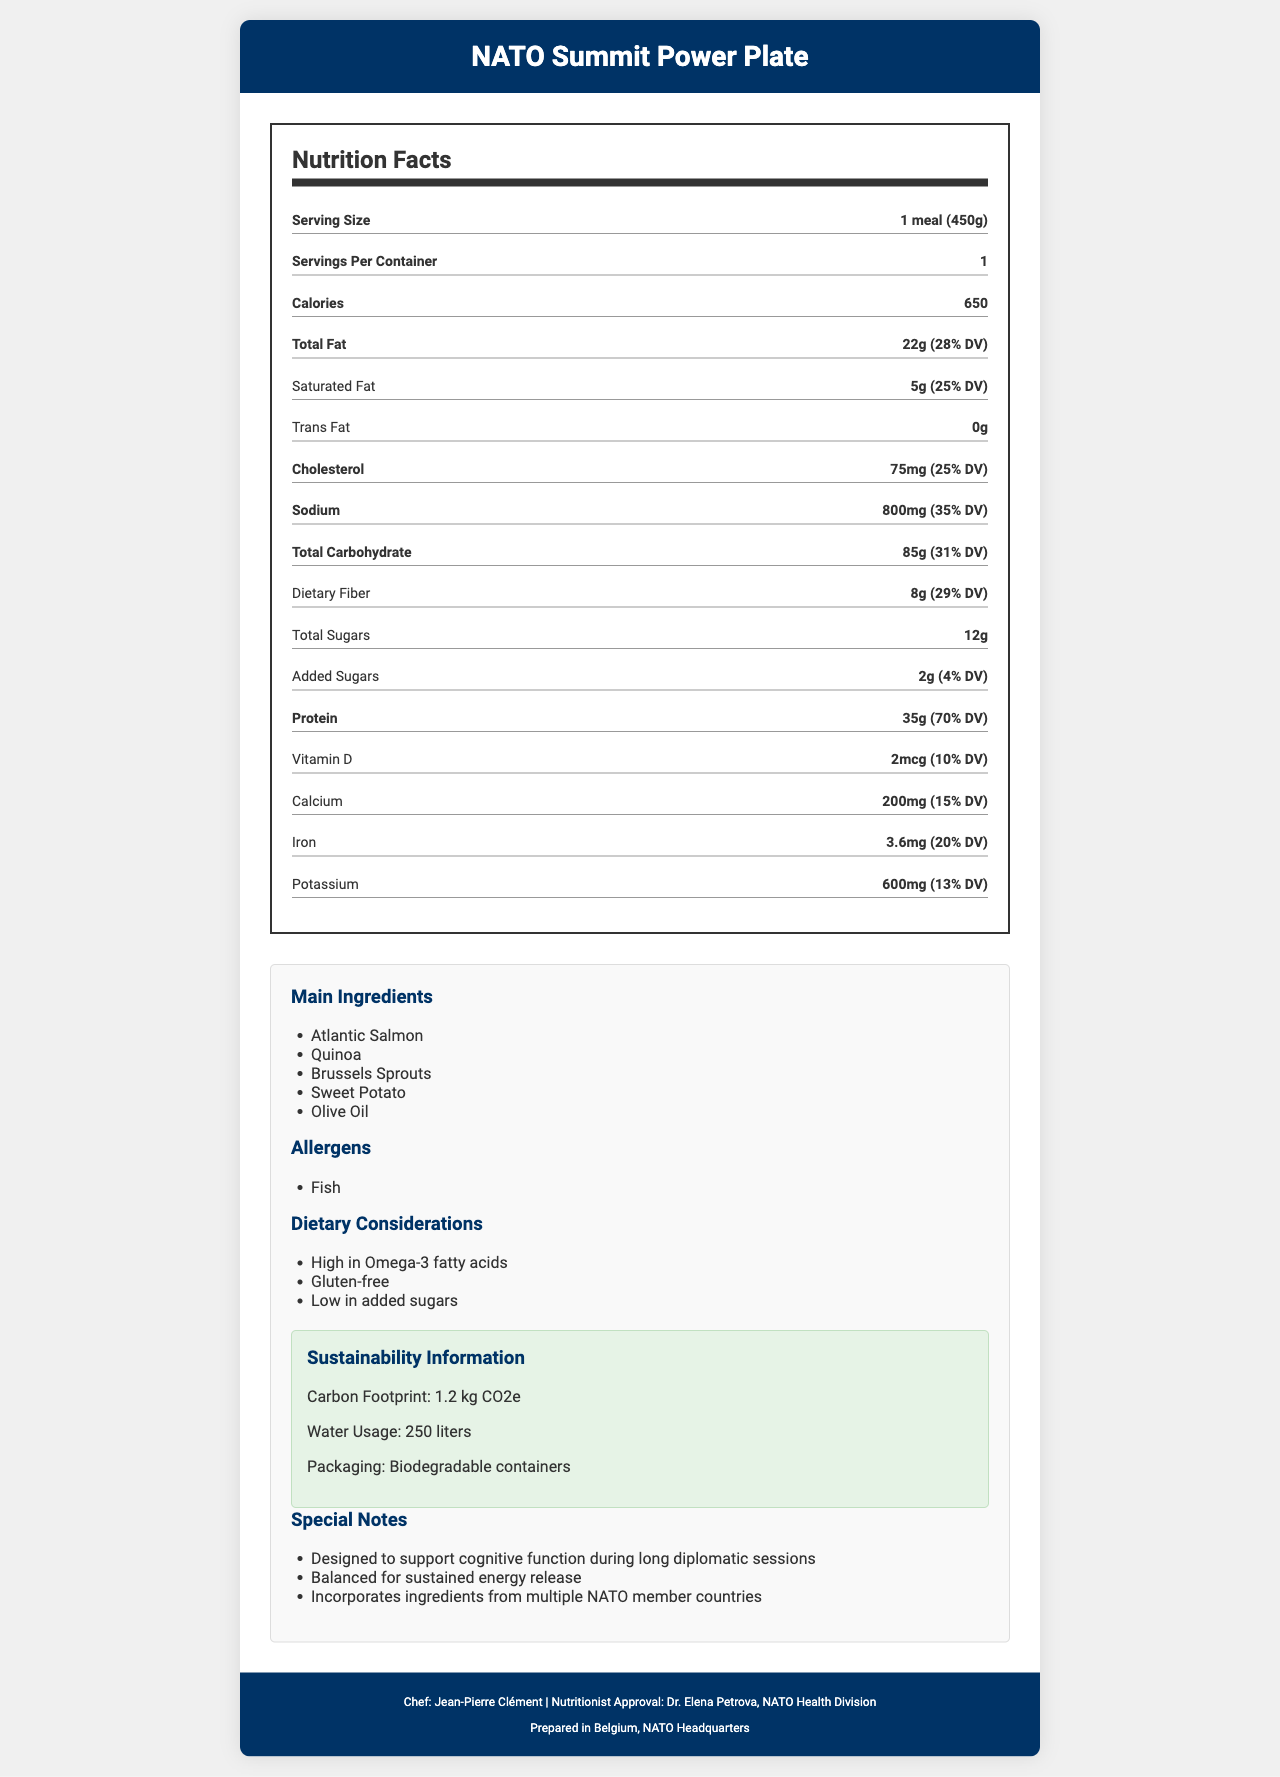what is the serving size of the meal? The serving size is clearly mentioned in the Nutrition Facts section as "1 meal (450g)".
Answer: 1 meal (450g) how many calories are in one meal? The Nutrition Facts section lists the calorie content as 650.
Answer: 650 what is the total amount of fat in grams and its daily value percentage? The Total Fat content is shown as 22g with a daily value percentage of 28%.
Answer: 22g, 28% which ingredient is the main source of protein in the meal? The main ingredients listed include Atlantic Salmon, which is known for its high protein content.
Answer: Atlantic Salmon does the meal contain any trans fat? The Nutrition Facts section indicates that the Trans Fat amount is 0g.
Answer: No how much sodium does the meal contain in milligrams and its daily value percentage? The Sodium content is mentioned as 800mg with a daily value percentage of 35%.
Answer: 800mg, 35% what is the carbon footprint of the meal? The Sustainability Information section lists the carbon footprint as 1.2 kg CO2e.
Answer: 1.2 kg CO2e which nutrient has the highest daily value percentage? A. Saturated Fat B. Protein C. Sodium D. Dietary Fiber Protein has a daily value percentage of 70%, which is the highest among the listed nutrients.
Answer: B. Protein how much added sugar is in the meal? A. 0g B. 2g C. 5g D. 12g The Nutrition Facts section lists Added Sugars as 2g.
Answer: B. 2g is this meal suitable for someone with a fish allergy? The Allergens section indicates that the meal contains fish.
Answer: No what are the dietary considerations mentioned for this meal? These considerations are listed under the Dietary Considerations section.
Answer: High in Omega-3 fatty acids, Gluten-free, Low in added sugars who prepared the meal and who approved the nutrition? The footer of the document lists the Chef's name as Jean-Pierre Clément and the Nutritionist's name as Dr. Elena Petrova.
Answer: Chef Jean-Pierre Clément, Nutritionist Dr. Elena Petrova describe the main idea of the document. The main goal is to inform readers about the nutritional content and unique features of the meal specially designed for NATO diplomatic summits, including its health benefits, sustainability, and international ingredient sourcing.
Answer: The document provides a comprehensive overview of the NATO Summit Power Plate, detailing its nutrition facts, ingredients, allergens, dietary considerations, sustainability information, special notes, and the names of the chef and nutritionist. where is the meal prepared? The footer of the document states that the meal is prepared in Belgium, NATO Headquarters.
Answer: Prepared in Belgium, NATO Headquarters can the water usage of this meal be determined from the document? The Sustainability Information section mentions the water usage as 250 liters.
Answer: Yes how many grams of dietary fiber does the meal have? The Nutrition Facts section lists Dietary Fiber content as 8g.
Answer: 8g what are the special notes mentioned for the meal? These notes are listed under the Special Notes section.
Answer: Designed to support cognitive function during long diplomatic sessions, Balanced for sustained energy release, Incorporates ingredients from multiple NATO member countries what is the percentage of iron's daily value in the meal? A. 10% B. 15% C. 20% D. 25% The Nutrition Facts section indicates the Iron content as 3.6 mg with a daily value percentage of 20%.
Answer: C. 20% what is the packaging material used for the meal? The Sustainability Information section states that biodegradable containers are used.
Answer: Biodegradable containers how much vitamin D does the meal provide? The Nutrition Facts section lists the Vitamin D content as 2 mcg.
Answer: 2 mcg what is the daily value percentage of total carbohydrates in the meal? The Nutrition Facts section indicates that Total Carbohydrate content is 85g with a daily value of 31%.
Answer: 31% what is the chef's middle name? The document only provides the chef's name as Jean-Pierre Clément without specifying a middle name.
Answer: Not enough information 